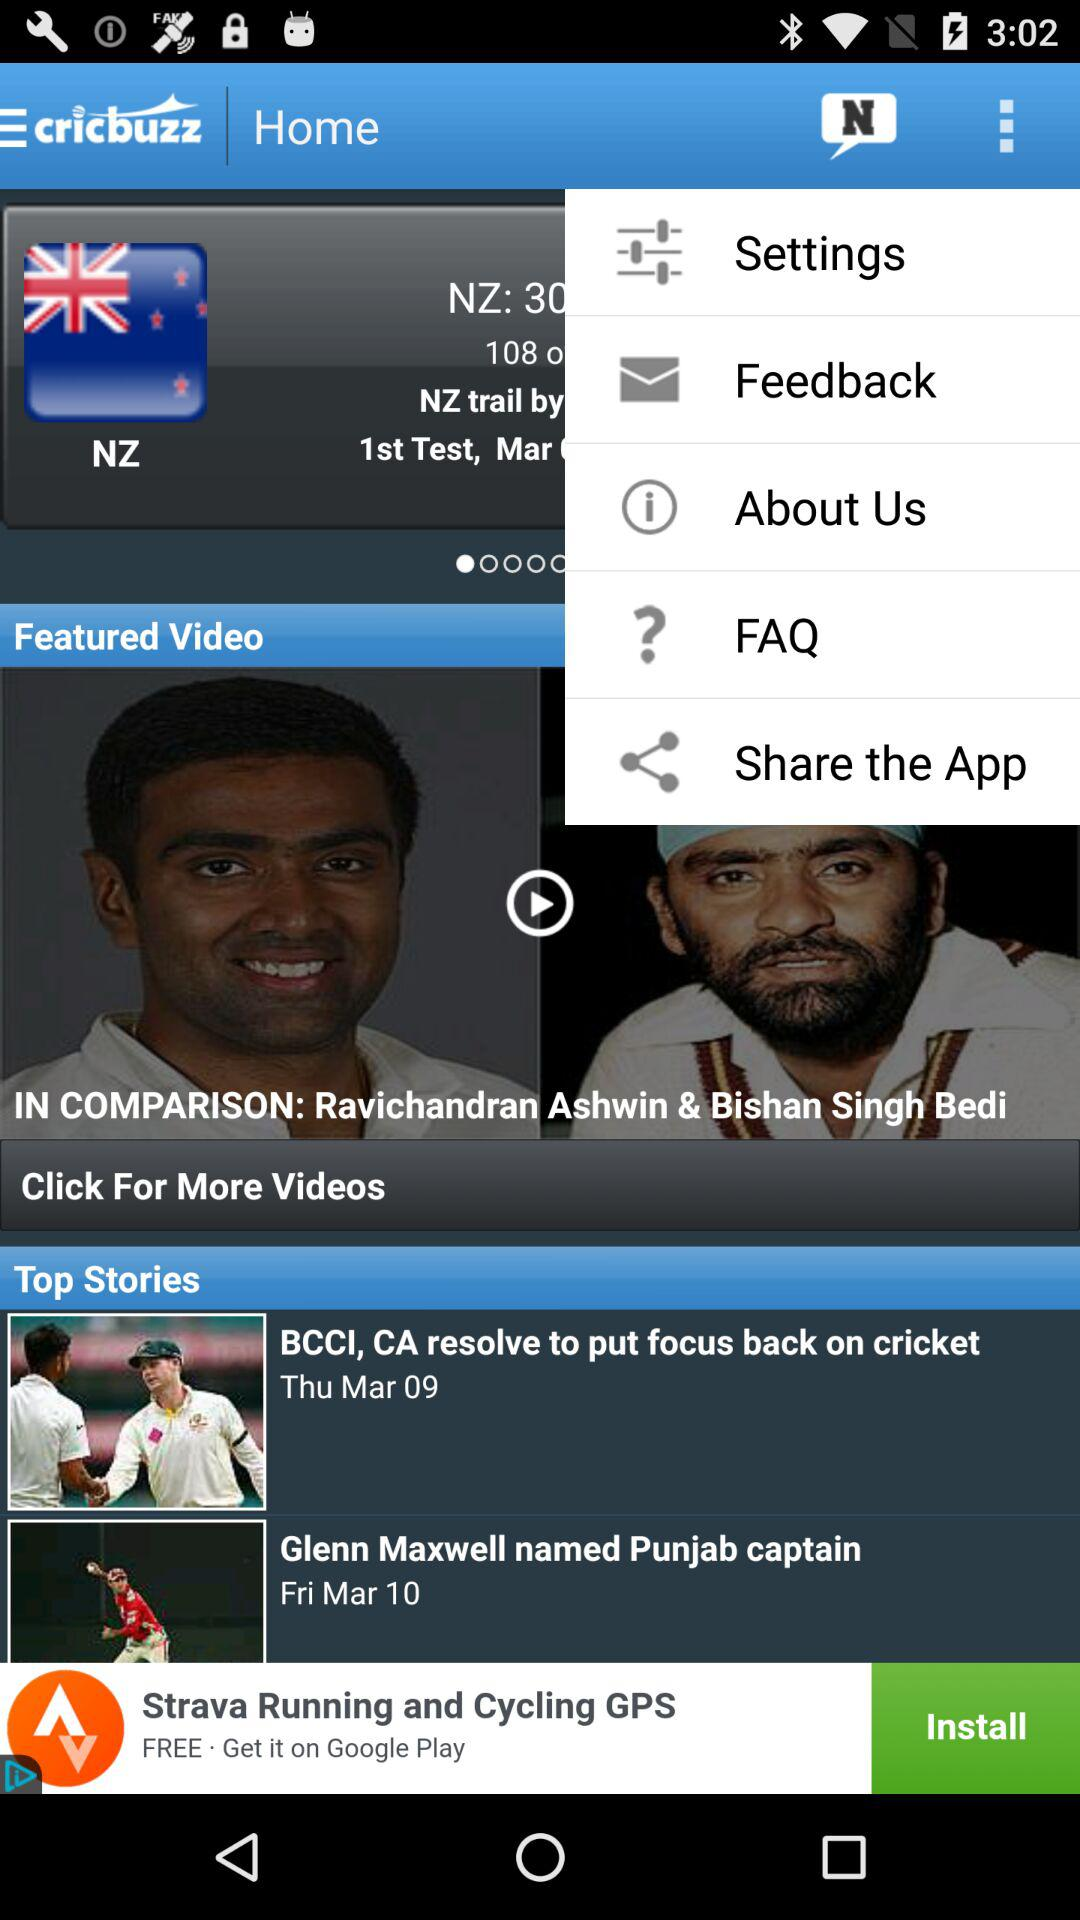On what date was the news "Glenn Maxwell named Punjab captain" published? The date is Friday, March 10. 